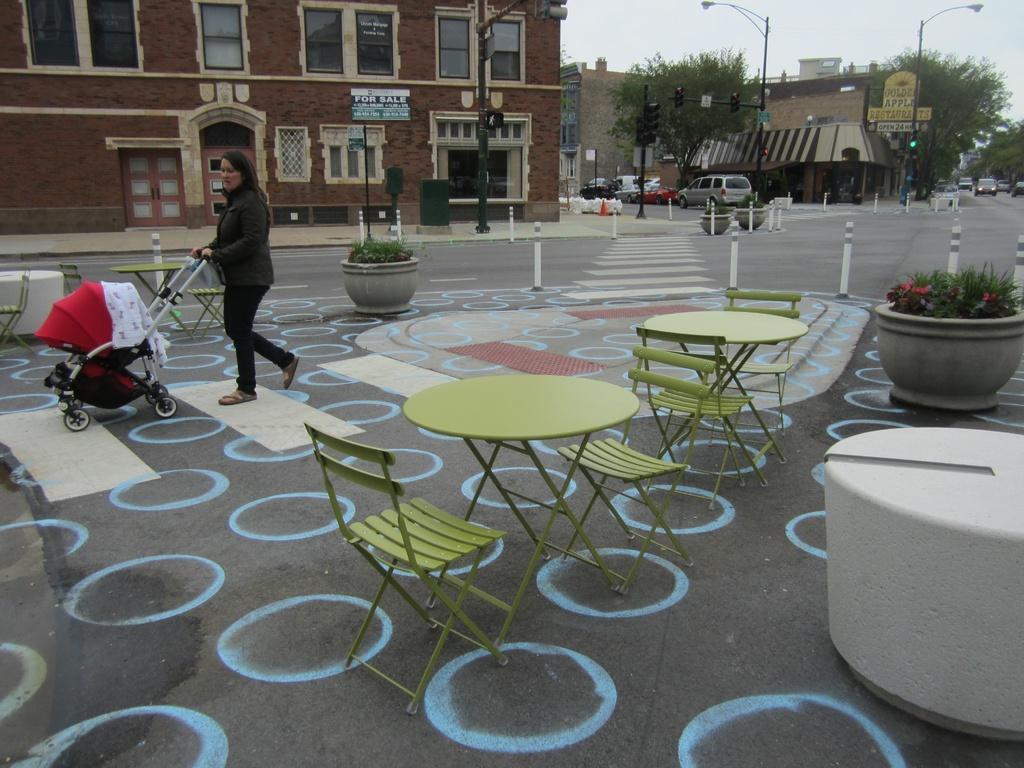Describe this image in one or two sentences. In this image, a woman is holding a stroller , she is walking on road. The right side and the middle, we can see some plants, tables, chairs. On left side of the image, we can see building, board, windows, glass windows,doors. In the middle, there so many poles, lights, traffic signals,few vehicles are there in the image. 